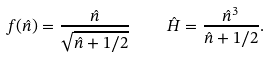<formula> <loc_0><loc_0><loc_500><loc_500>f ( \hat { n } ) = \frac { \hat { n } } { \sqrt { \hat { n } + 1 / 2 } } \quad \hat { H } = \frac { \hat { n } ^ { 3 } } { \hat { n } + 1 / 2 } .</formula> 